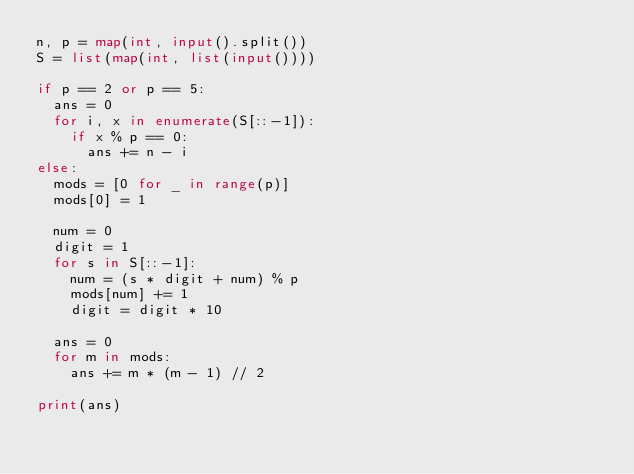<code> <loc_0><loc_0><loc_500><loc_500><_Python_>n, p = map(int, input().split())
S = list(map(int, list(input())))

if p == 2 or p == 5:
  ans = 0
  for i, x in enumerate(S[::-1]):
    if x % p == 0:
      ans += n - i
else:
  mods = [0 for _ in range(p)]
  mods[0] = 1

  num = 0
  digit = 1
  for s in S[::-1]:
    num = (s * digit + num) % p
    mods[num] += 1
    digit = digit * 10
  
  ans = 0
  for m in mods:
    ans += m * (m - 1) // 2

print(ans)
</code> 